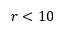<formula> <loc_0><loc_0><loc_500><loc_500>r < 1 0</formula> 